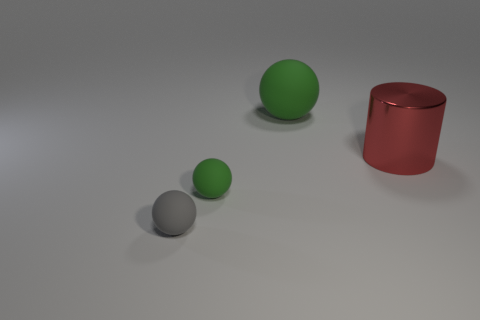There is a shiny thing; is its shape the same as the rubber thing behind the red metal cylinder?
Give a very brief answer. No. There is a large thing to the left of the large cylinder; is it the same shape as the large red thing?
Your answer should be very brief. No. How many objects are left of the big green ball and to the right of the large green matte thing?
Give a very brief answer. 0. What number of other objects are the same size as the cylinder?
Ensure brevity in your answer.  1. Are there an equal number of red cylinders that are to the left of the big metallic object and balls?
Ensure brevity in your answer.  No. Does the object that is to the right of the large green matte thing have the same color as the rubber ball behind the big metal object?
Offer a very short reply. No. What is the material of the ball that is to the right of the gray ball and in front of the large rubber object?
Keep it short and to the point. Rubber. The metallic cylinder has what color?
Your response must be concise. Red. How many other objects are the same shape as the large green rubber object?
Give a very brief answer. 2. Are there an equal number of small matte things behind the gray rubber ball and things behind the tiny green matte thing?
Ensure brevity in your answer.  No. 